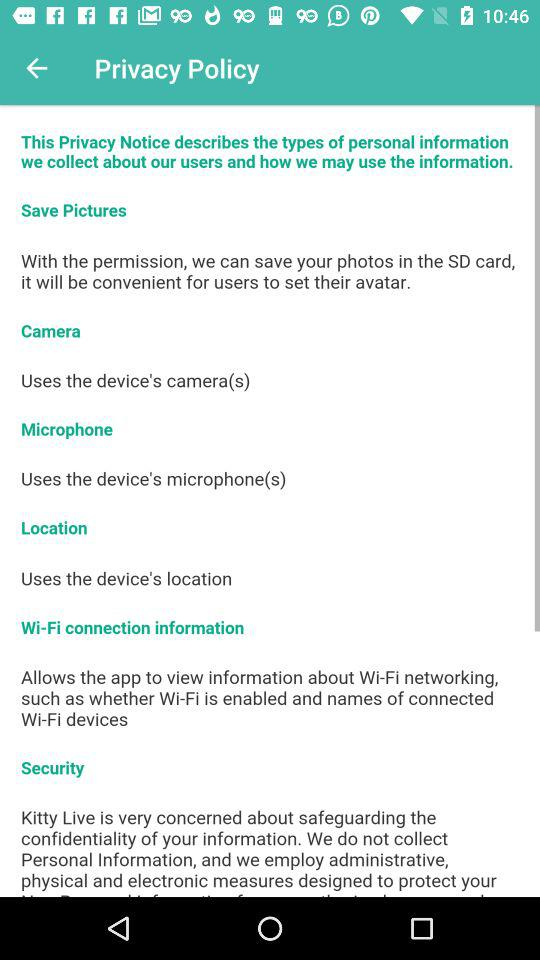What is the name of the application? The name of the application is "Kitty Live". 